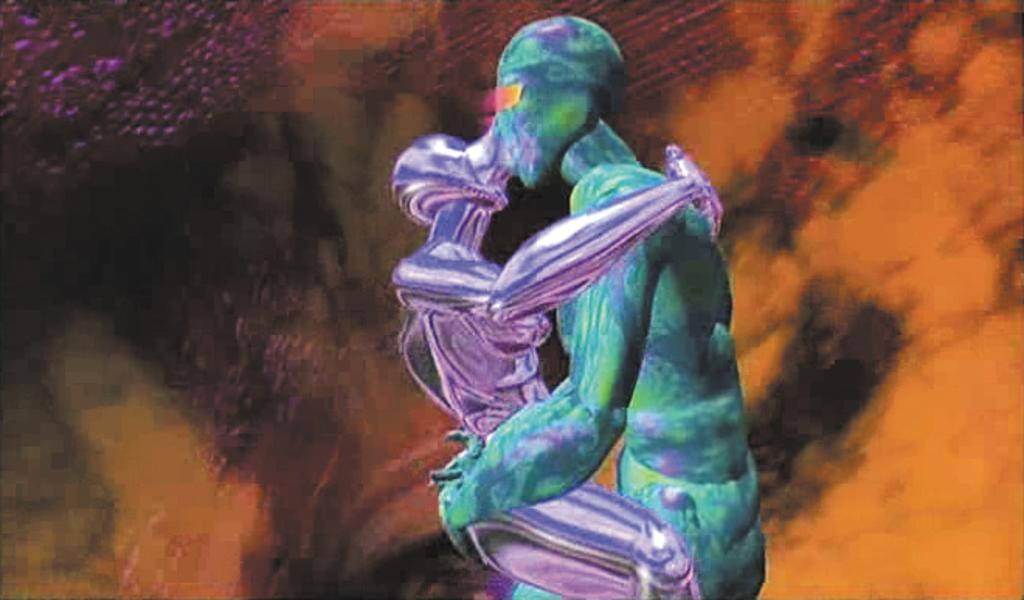What is the main subject of the image? There is a painting in the image. What is depicted in the painting? The painting depicts two persons. Can you describe the background of the painting? There are different colors in the background of the painting. How many judges are present in the painting? There are no judges depicted in the painting; it features two persons. What type of flock can be seen flying in the background of the painting? There is no flock present in the painting; it only depicts two persons and different colors in the background. 